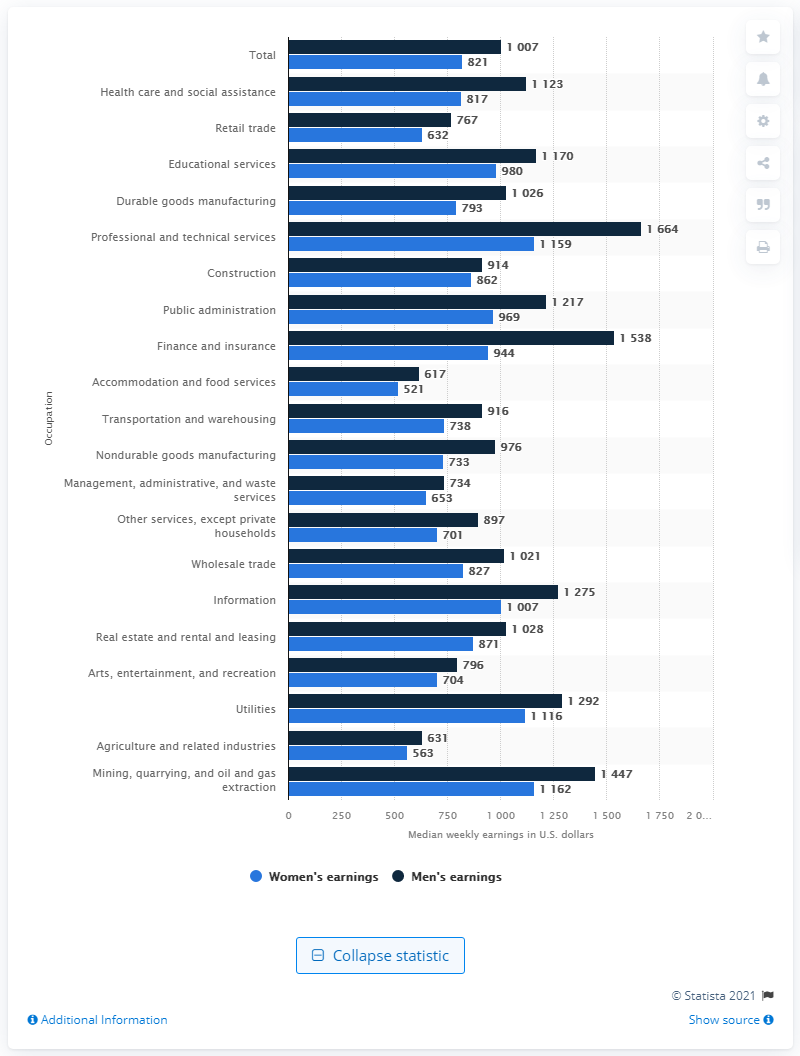Give some essential details in this illustration. In 2019, female retail workers earned an average of $632 per week, according to data. 